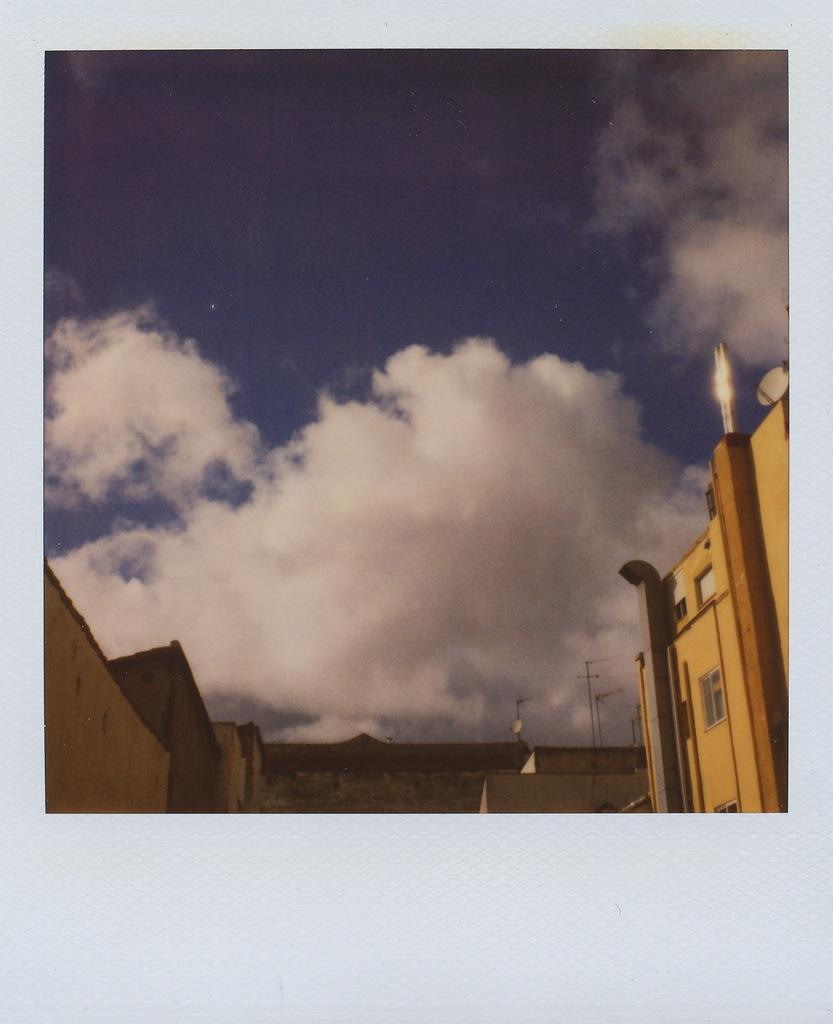What type of structures can be seen in the image? There are buildings in the image. What can be observed in the sky in the image? There are clouds visible in the image. What type of window can be seen on the buildings in the image? There is no specific window mentioned or visible in the image; only the buildings themselves are described. 